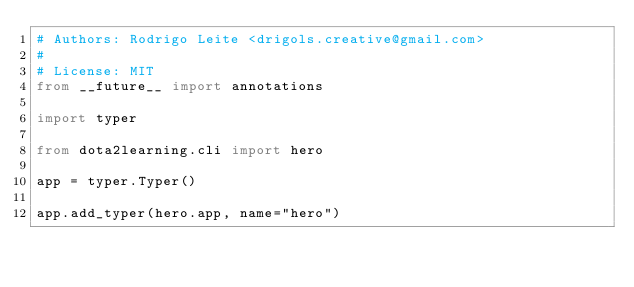<code> <loc_0><loc_0><loc_500><loc_500><_Python_># Authors: Rodrigo Leite <drigols.creative@gmail.com>
#
# License: MIT
from __future__ import annotations

import typer

from dota2learning.cli import hero

app = typer.Typer()

app.add_typer(hero.app, name="hero")
</code> 